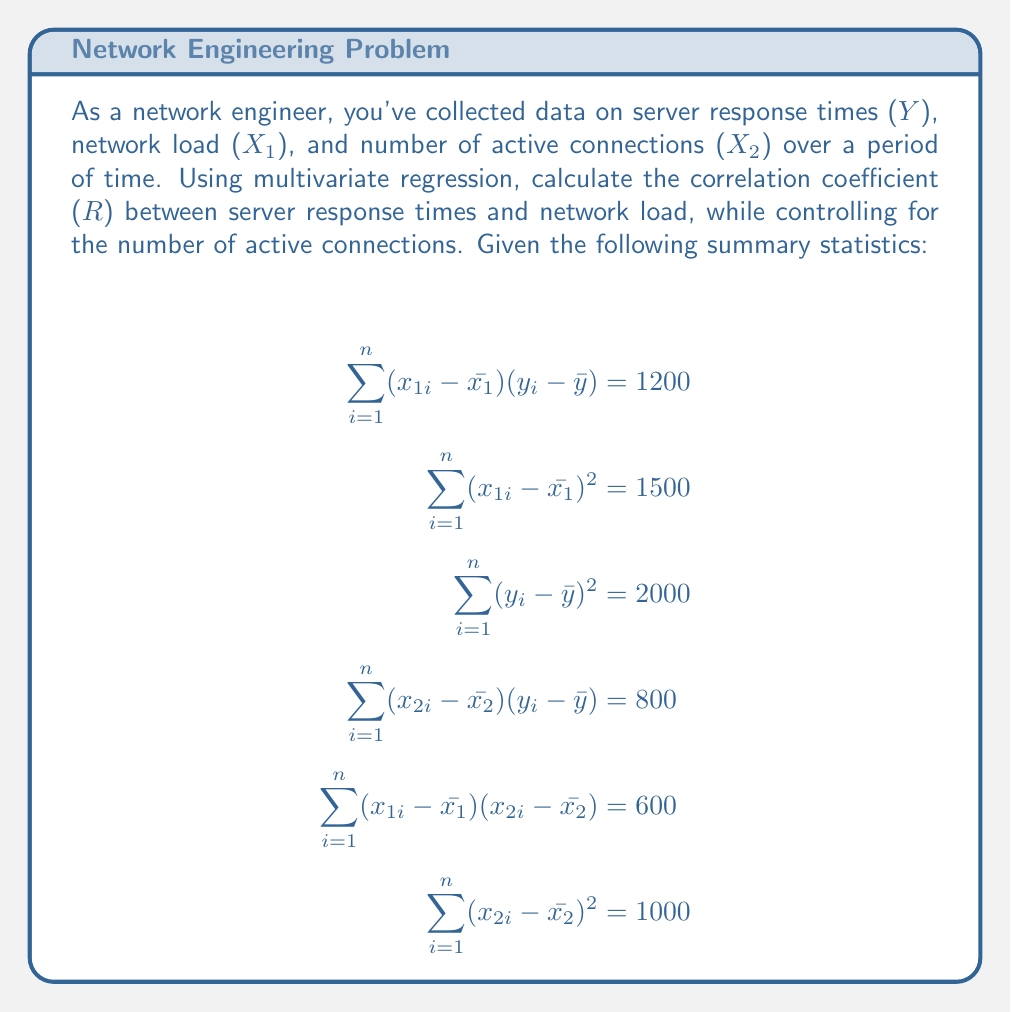Can you answer this question? To calculate the correlation coefficient between server response times and network load while controlling for the number of active connections, we need to use partial correlation. The steps are as follows:

1. Calculate the simple correlation coefficients:

   a) Between Y and X1: 
   $$ r_{yx_1} = \frac{\sum_{i=1}^n (x_{1i} - \bar{x_1})(y_i - \bar{y})}{\sqrt{\sum_{i=1}^n (x_{1i} - \bar{x_1})^2 \sum_{i=1}^n (y_i - \bar{y})^2}} = \frac{1200}{\sqrt{1500 \cdot 2000}} = 0.6928 $$

   b) Between Y and X2:
   $$ r_{yx_2} = \frac{\sum_{i=1}^n (x_{2i} - \bar{x_2})(y_i - \bar{y})}{\sqrt{\sum_{i=1}^n (x_{2i} - \bar{x_2})^2 \sum_{i=1}^n (y_i - \bar{y})^2}} = \frac{800}{\sqrt{1000 \cdot 2000}} = 0.5657 $$

   c) Between X1 and X2:
   $$ r_{x_1x_2} = \frac{\sum_{i=1}^n (x_{1i} - \bar{x_1})(x_{2i} - \bar{x_2})}{\sqrt{\sum_{i=1}^n (x_{1i} - \bar{x_1})^2 \sum_{i=1}^n (x_{2i} - \bar{x_2})^2}} = \frac{600}{\sqrt{1500 \cdot 1000}} = 0.4899 $$

2. Calculate the partial correlation coefficient between Y and X1, controlling for X2:

   $$ r_{yx_1.x_2} = \frac{r_{yx_1} - r_{yx_2}r_{x_1x_2}}{\sqrt{(1-r_{yx_2}^2)(1-r_{x_1x_2}^2)}} $$

3. Substitute the values:

   $$ r_{yx_1.x_2} = \frac{0.6928 - 0.5657 \cdot 0.4899}{\sqrt{(1-0.5657^2)(1-0.4899^2)}} $$

4. Calculate the final result:

   $$ r_{yx_1.x_2} = \frac{0.6928 - 0.2771}{\sqrt{0.6800 \cdot 0.7600}} = \frac{0.4157}{0.7184} = 0.5787 $$

This partial correlation coefficient represents the correlation between server response times and network load, while controlling for the number of active connections.
Answer: The correlation coefficient (R) between server response times and network load, controlling for the number of active connections, is approximately 0.5787. 